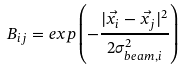Convert formula to latex. <formula><loc_0><loc_0><loc_500><loc_500>B _ { i j } = e x p \left ( - \frac { | \vec { x _ { i } } - \vec { x _ { j } } | ^ { 2 } } { 2 \sigma _ { b e a m , i } ^ { 2 } } \right )</formula> 